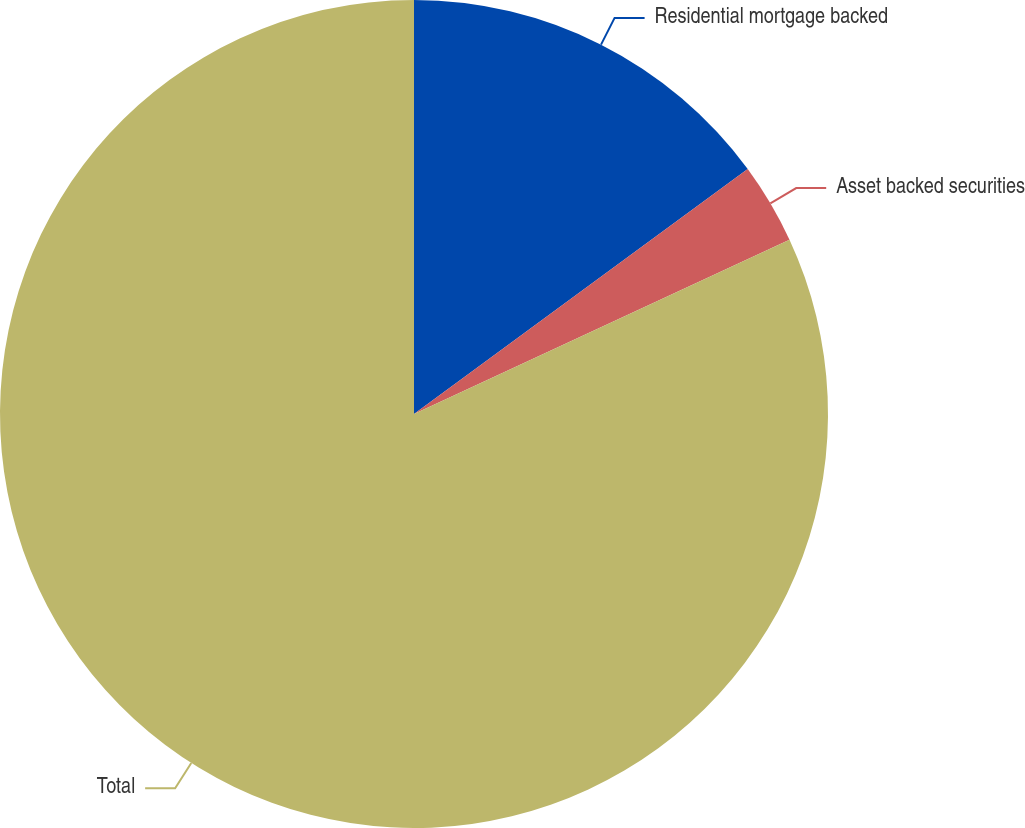Convert chart to OTSL. <chart><loc_0><loc_0><loc_500><loc_500><pie_chart><fcel>Residential mortgage backed<fcel>Asset backed securities<fcel>Total<nl><fcel>14.92%<fcel>3.16%<fcel>81.91%<nl></chart> 